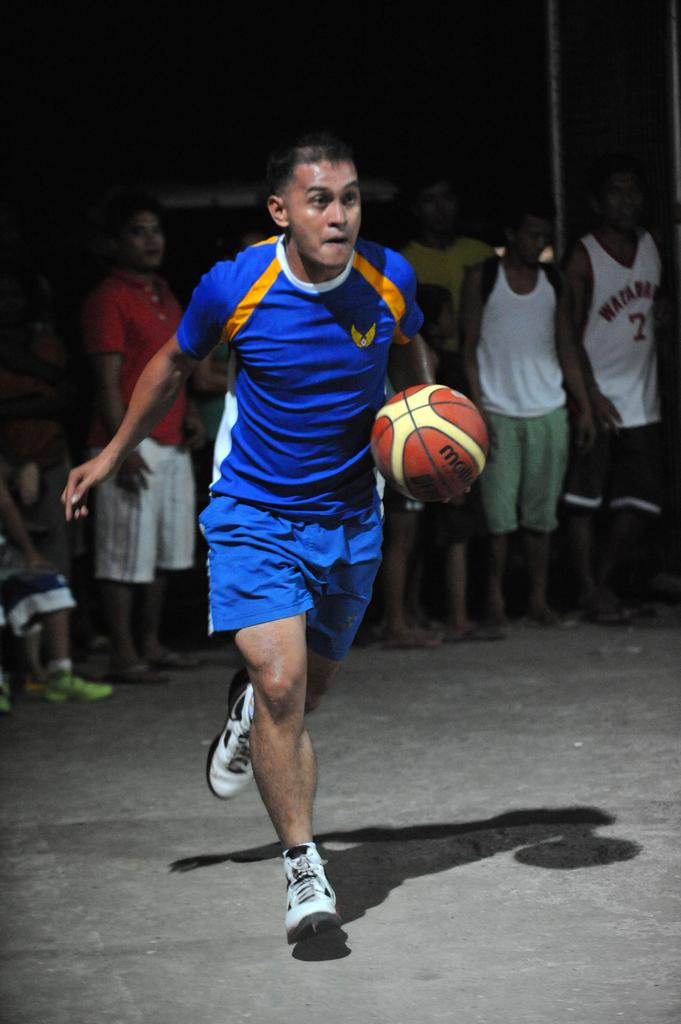Who is present in the image? There are people in the image. What is one of the people doing in the image? A man is running in the image. What is the man holding while running? The man is holding a ball. What type of coal can be seen in the image? There is no coal present in the image. How many sheep are visible in the image? There are no sheep present in the image. 